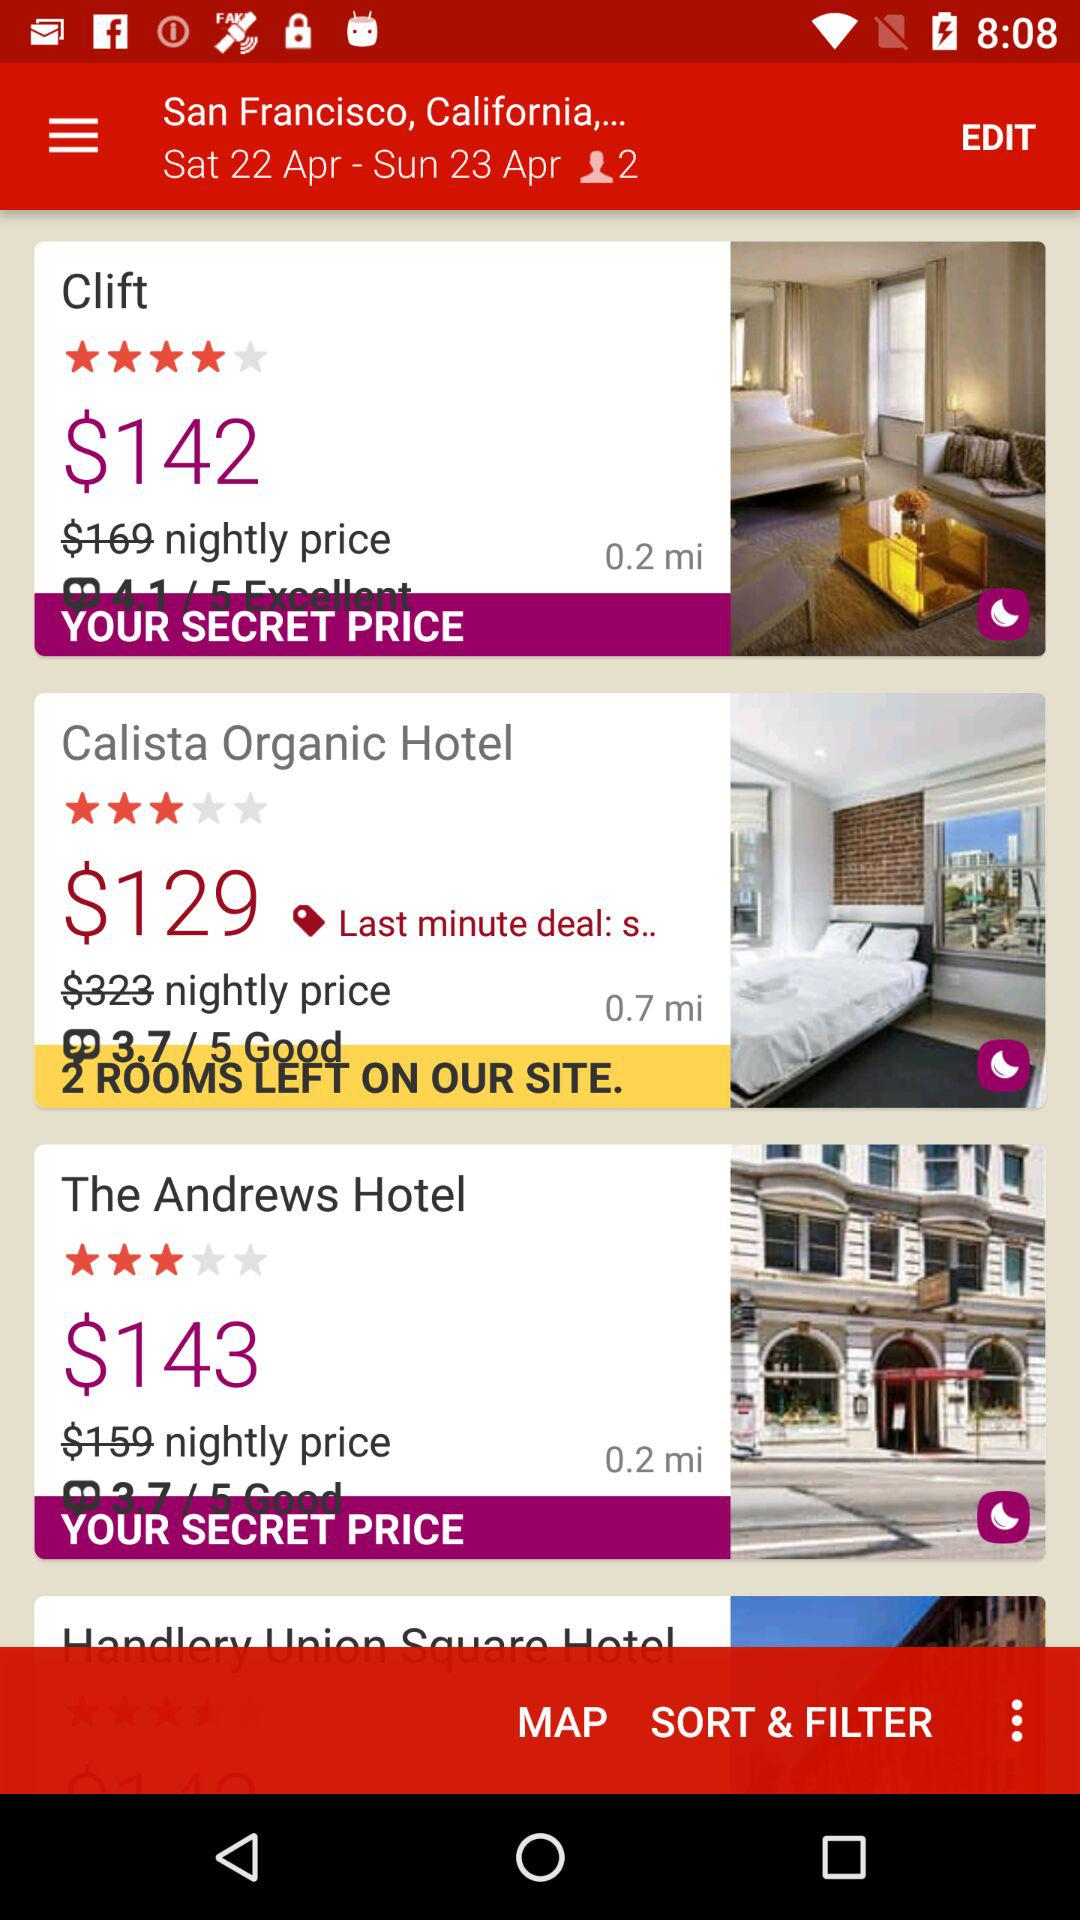What is the booking price after discount for "Clift"? The booking price after discount for "Clift" is $142. 